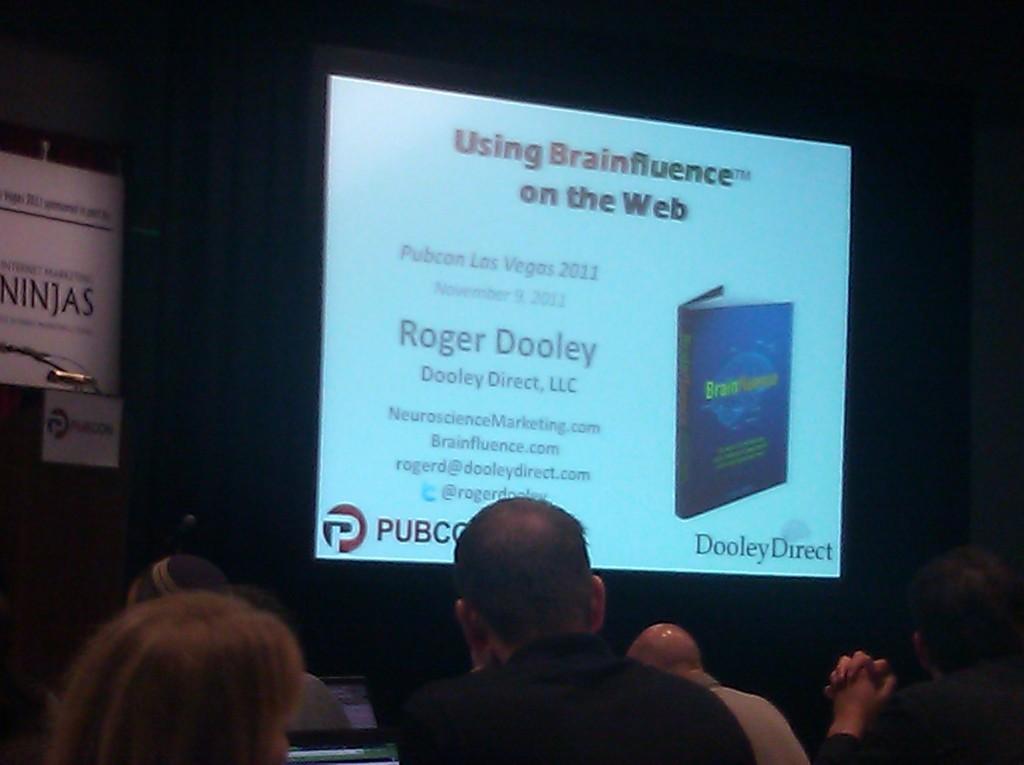Can you describe this image briefly? In this image we can see these people are sitting on the chairs. The background of the image is dark, where we can see the podium, boards and the projector screen on which something is displayed. 